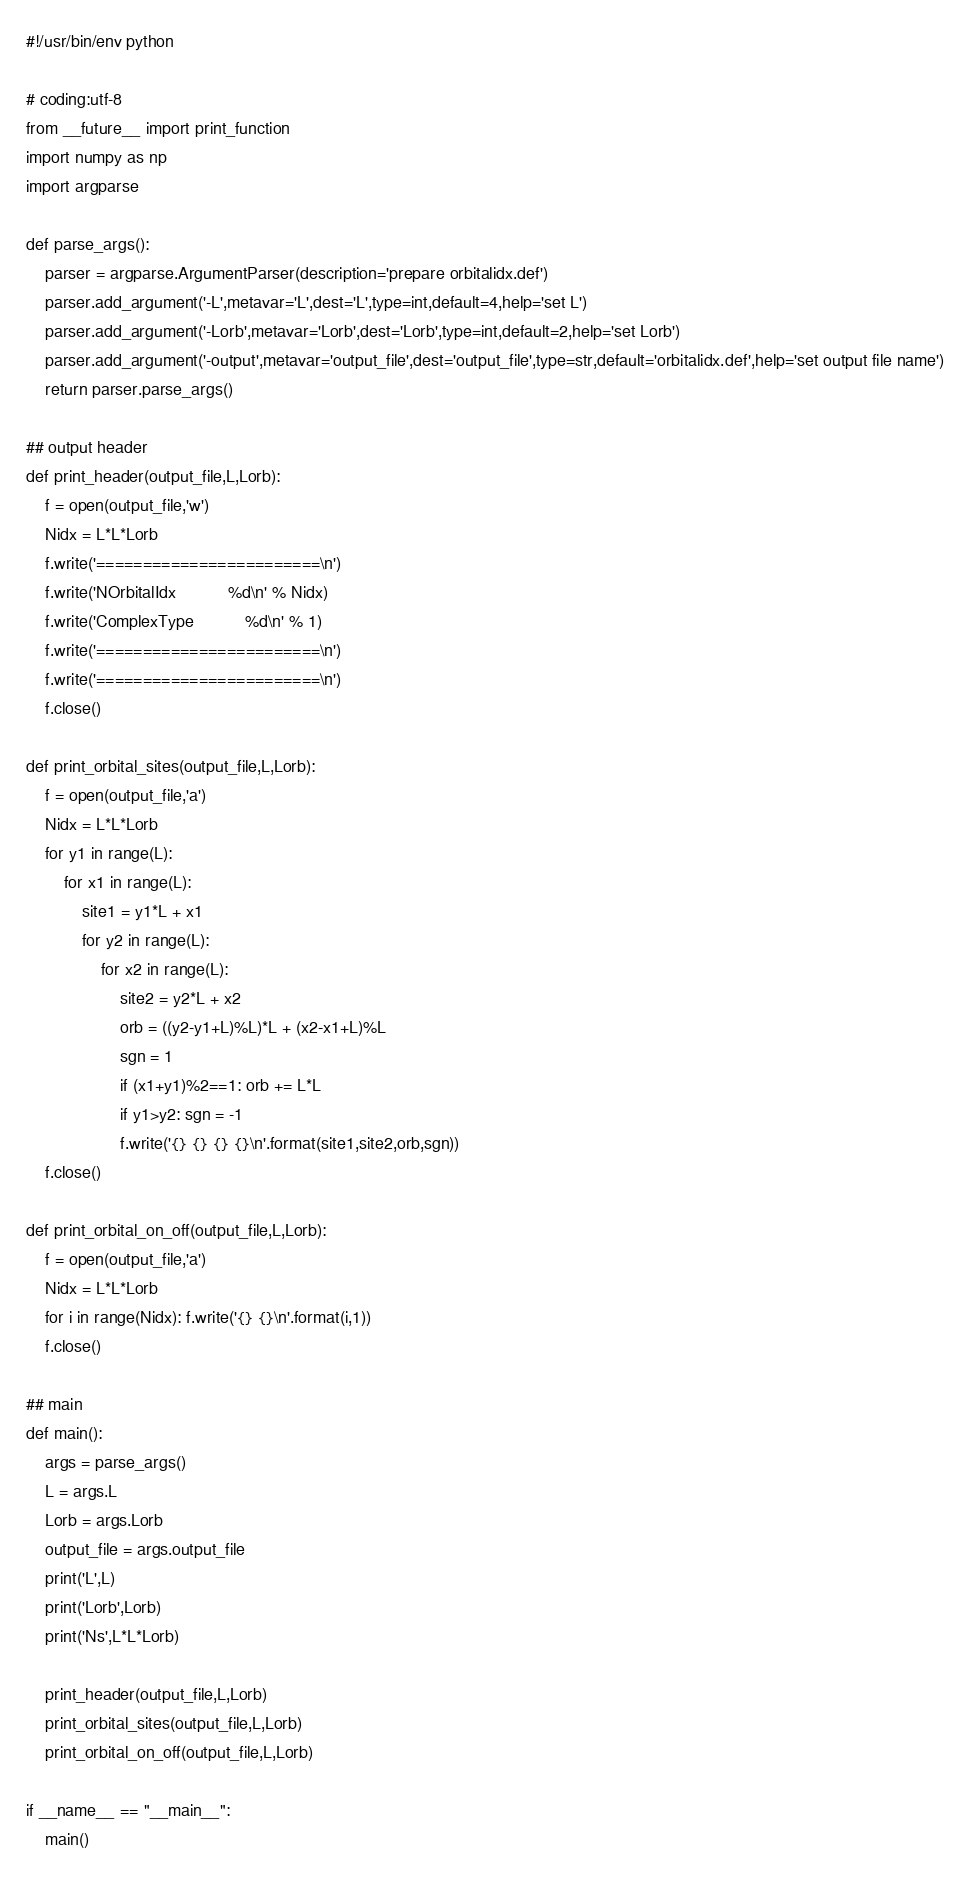<code> <loc_0><loc_0><loc_500><loc_500><_Python_>#!/usr/bin/env python

# coding:utf-8
from __future__ import print_function
import numpy as np
import argparse

def parse_args():
    parser = argparse.ArgumentParser(description='prepare orbitalidx.def')
    parser.add_argument('-L',metavar='L',dest='L',type=int,default=4,help='set L')
    parser.add_argument('-Lorb',metavar='Lorb',dest='Lorb',type=int,default=2,help='set Lorb')
    parser.add_argument('-output',metavar='output_file',dest='output_file',type=str,default='orbitalidx.def',help='set output file name')
    return parser.parse_args()

## output header
def print_header(output_file,L,Lorb):
    f = open(output_file,'w')
    Nidx = L*L*Lorb
    f.write('========================\n')
    f.write('NOrbitalIdx           %d\n' % Nidx)
    f.write('ComplexType           %d\n' % 1)
    f.write('========================\n')
    f.write('========================\n')
    f.close()

def print_orbital_sites(output_file,L,Lorb):
    f = open(output_file,'a')
    Nidx = L*L*Lorb
    for y1 in range(L):
        for x1 in range(L):
            site1 = y1*L + x1
            for y2 in range(L):
                for x2 in range(L):
                    site2 = y2*L + x2
                    orb = ((y2-y1+L)%L)*L + (x2-x1+L)%L
                    sgn = 1
                    if (x1+y1)%2==1: orb += L*L
                    if y1>y2: sgn = -1
                    f.write('{} {} {} {}\n'.format(site1,site2,orb,sgn))
    f.close()

def print_orbital_on_off(output_file,L,Lorb):
    f = open(output_file,'a')
    Nidx = L*L*Lorb
    for i in range(Nidx): f.write('{} {}\n'.format(i,1))
    f.close()

## main
def main():
    args = parse_args()
    L = args.L
    Lorb = args.Lorb
    output_file = args.output_file
    print('L',L)
    print('Lorb',Lorb)
    print('Ns',L*L*Lorb)

    print_header(output_file,L,Lorb)
    print_orbital_sites(output_file,L,Lorb)
    print_orbital_on_off(output_file,L,Lorb)

if __name__ == "__main__":
    main()
</code> 